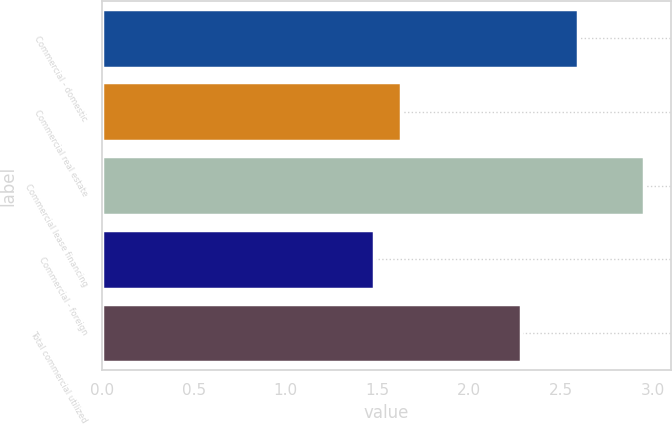Convert chart. <chart><loc_0><loc_0><loc_500><loc_500><bar_chart><fcel>Commercial - domestic<fcel>Commercial real estate<fcel>Commercial lease financing<fcel>Commercial - foreign<fcel>Total commercial utilized<nl><fcel>2.59<fcel>1.63<fcel>2.95<fcel>1.48<fcel>2.28<nl></chart> 